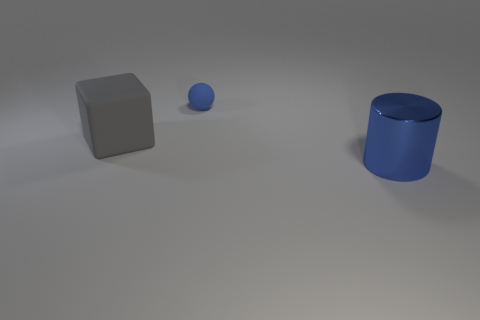Add 2 big gray matte cubes. How many objects exist? 5 Subtract all cubes. How many objects are left? 2 Add 1 metal things. How many metal things are left? 2 Add 1 big gray objects. How many big gray objects exist? 2 Subtract 0 green balls. How many objects are left? 3 Subtract all blue cylinders. Subtract all big metal cylinders. How many objects are left? 1 